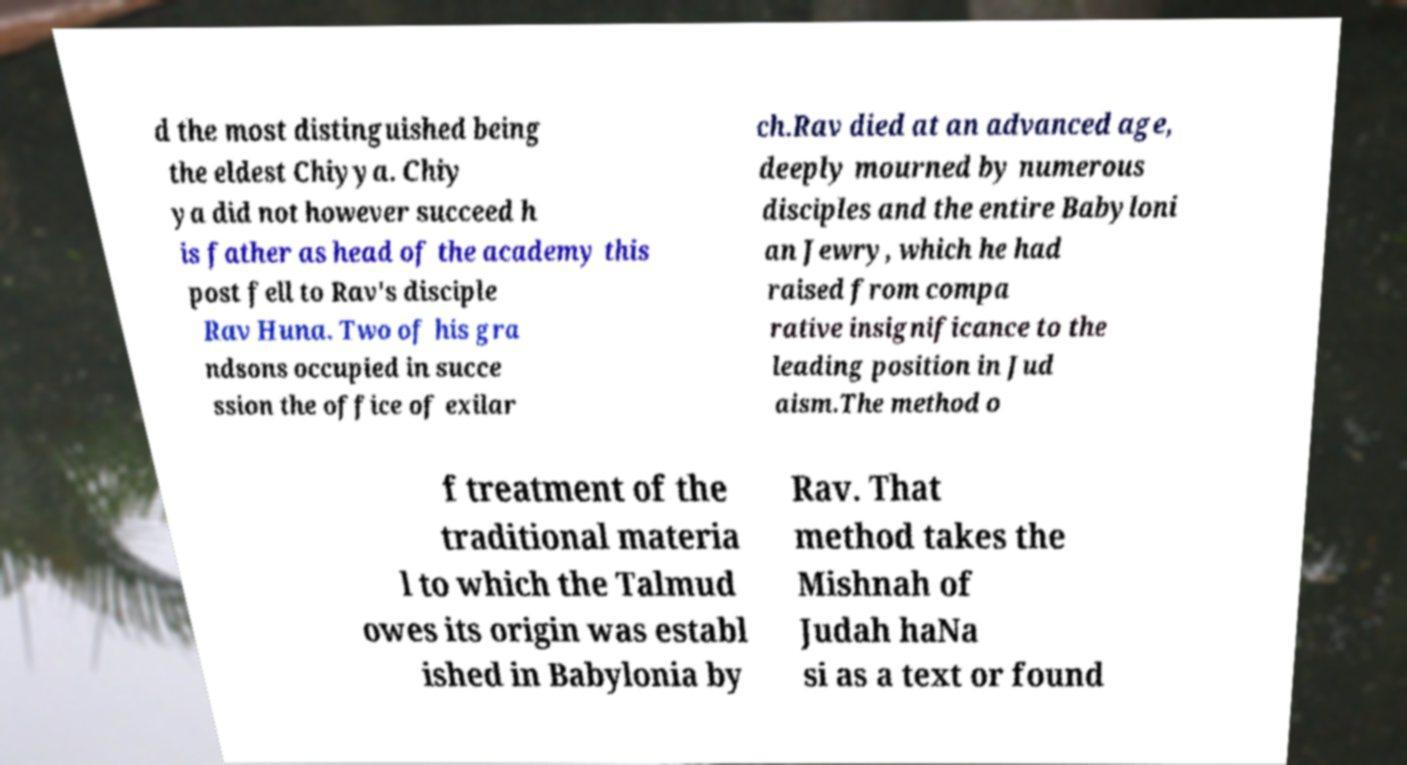Please read and relay the text visible in this image. What does it say? d the most distinguished being the eldest Chiyya. Chiy ya did not however succeed h is father as head of the academy this post fell to Rav's disciple Rav Huna. Two of his gra ndsons occupied in succe ssion the office of exilar ch.Rav died at an advanced age, deeply mourned by numerous disciples and the entire Babyloni an Jewry, which he had raised from compa rative insignificance to the leading position in Jud aism.The method o f treatment of the traditional materia l to which the Talmud owes its origin was establ ished in Babylonia by Rav. That method takes the Mishnah of Judah haNa si as a text or found 